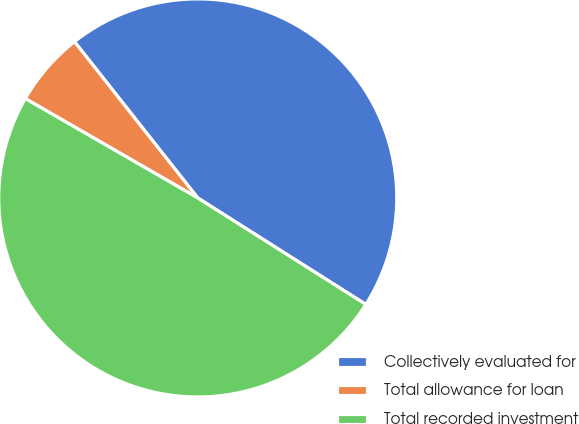Convert chart to OTSL. <chart><loc_0><loc_0><loc_500><loc_500><pie_chart><fcel>Collectively evaluated for<fcel>Total allowance for loan<fcel>Total recorded investment<nl><fcel>44.62%<fcel>6.05%<fcel>49.33%<nl></chart> 